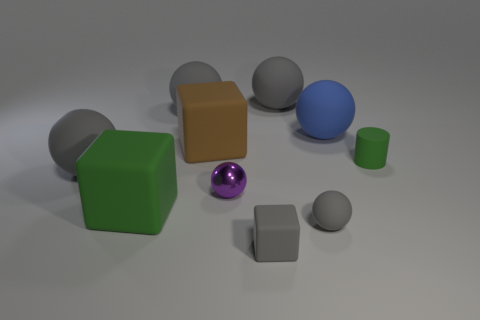Do the green rubber object behind the small metal ball and the green block that is left of the brown matte block have the same size?
Ensure brevity in your answer.  No. The gray object that is both in front of the big blue ball and behind the small metal thing has what shape?
Keep it short and to the point. Sphere. Is there another object that has the same material as the tiny green thing?
Your answer should be very brief. Yes. What is the material of the tiny ball that is the same color as the tiny rubber block?
Offer a terse response. Rubber. Is the material of the tiny sphere that is to the right of the gray matte block the same as the small sphere behind the tiny gray ball?
Your answer should be compact. No. Are there more brown rubber cubes than large yellow rubber spheres?
Provide a short and direct response. Yes. What color is the big object that is left of the green rubber object on the left side of the large gray ball on the right side of the tiny gray block?
Your response must be concise. Gray. There is a block on the right side of the purple thing; does it have the same color as the matte cube that is behind the tiny green rubber cylinder?
Give a very brief answer. No. How many big blocks are right of the large cube in front of the brown matte object?
Provide a succinct answer. 1. Is there a tiny blue metallic object?
Your answer should be compact. No. 